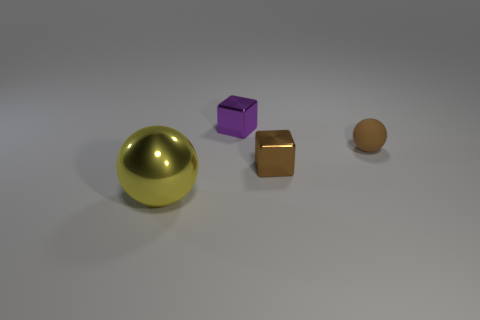There is a cube that is the same color as the tiny rubber object; what material is it?
Provide a short and direct response. Metal. Do the small matte object and the small cube that is to the right of the purple metal thing have the same color?
Give a very brief answer. Yes. Are there any other things that have the same material as the small brown ball?
Your response must be concise. No. How many tiny matte spheres are on the right side of the ball that is to the right of the purple metal thing?
Provide a short and direct response. 0. There is a tiny shiny thing that is in front of the matte object; is it the same color as the small matte ball?
Provide a succinct answer. Yes. There is a ball that is on the right side of the ball that is on the left side of the small brown rubber sphere; is there a yellow object that is to the left of it?
Offer a terse response. Yes. What shape is the object that is in front of the tiny matte ball and to the right of the purple thing?
Provide a short and direct response. Cube. Are there any blocks of the same color as the small matte sphere?
Ensure brevity in your answer.  Yes. What color is the tiny thing that is on the left side of the brown object that is in front of the rubber object?
Provide a succinct answer. Purple. There is a metallic object that is in front of the small brown thing that is in front of the ball that is behind the large object; how big is it?
Give a very brief answer. Large. 